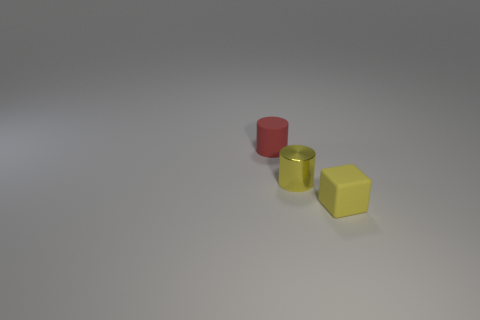There is a yellow object to the right of the tiny yellow thing left of the block; what size is it?
Provide a short and direct response. Small. Is the number of metallic objects that are in front of the rubber cylinder the same as the number of small yellow shiny objects that are to the right of the yellow metal thing?
Keep it short and to the point. No. Is there a yellow cylinder to the left of the rubber object that is on the right side of the red matte thing?
Your answer should be very brief. Yes. The yellow thing that is the same material as the small red cylinder is what shape?
Provide a short and direct response. Cube. Are there any other things that have the same color as the small block?
Keep it short and to the point. Yes. There is a small red cylinder that is left of the thing in front of the tiny yellow cylinder; what is it made of?
Provide a short and direct response. Rubber. Are there any other small metal objects of the same shape as the tiny red object?
Offer a very short reply. Yes. How many other things are the same shape as the metallic object?
Your answer should be very brief. 1. What is the size of the cylinder in front of the tiny red thing?
Give a very brief answer. Small. Do the yellow shiny object and the rubber cylinder have the same size?
Provide a short and direct response. Yes. 